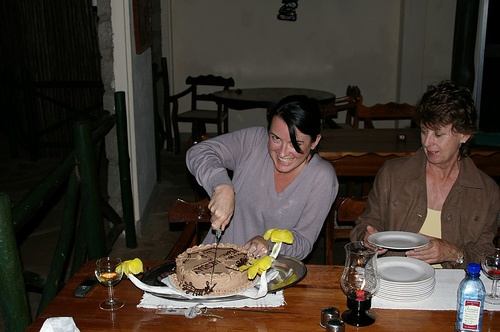Describe the objects in this image and their specific colors. I can see dining table in black, maroon, darkgray, and lightgray tones, people in black, maroon, and brown tones, people in black and gray tones, dining table in black, maroon, and gray tones, and cake in black, gray, and tan tones in this image. 